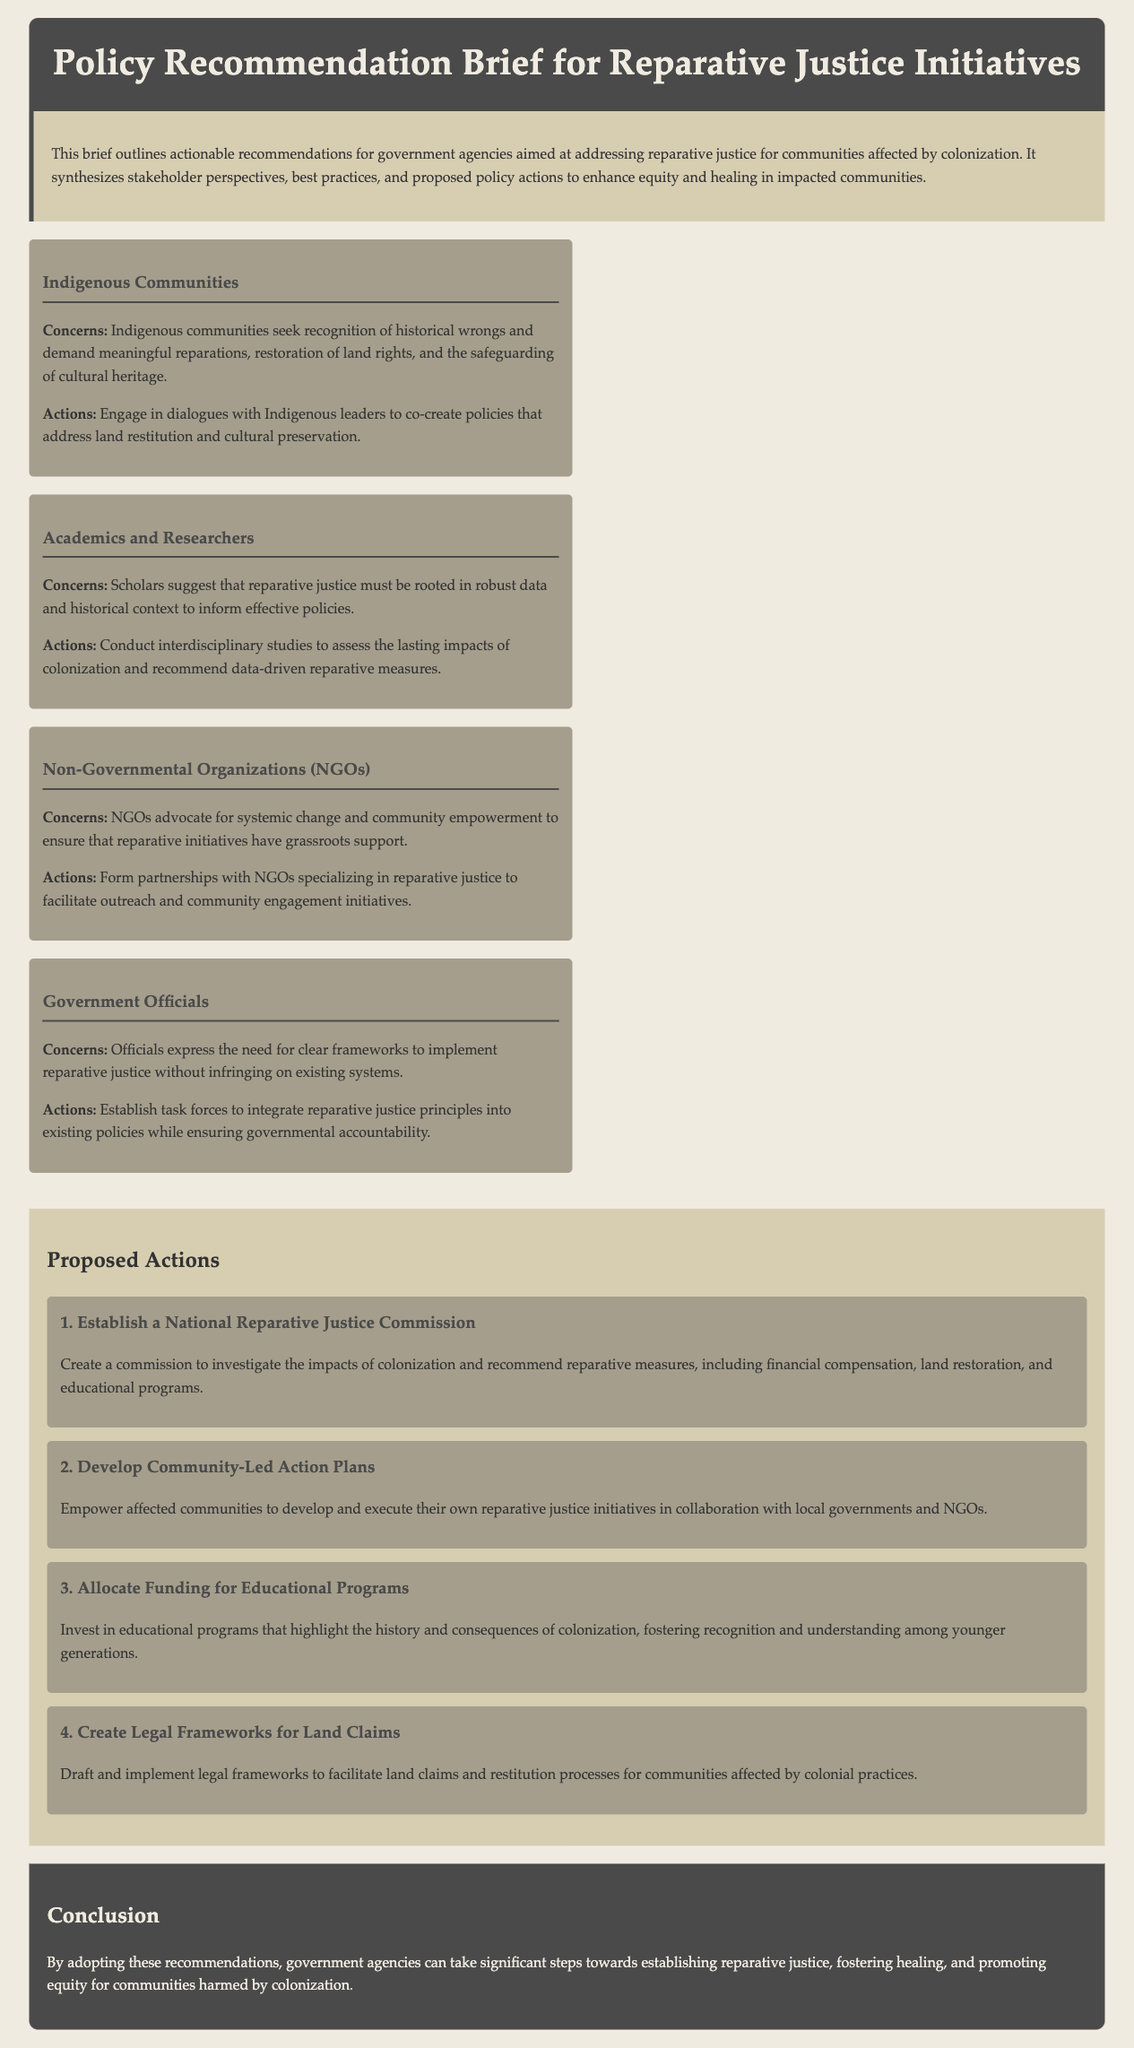what is the title of the document? The title is provided in the header section of the document.
Answer: Policy Recommendation Brief for Reparative Justice Initiatives who are the four stakeholders mentioned? The stakeholders are listed in the stakeholder perspectives section.
Answer: Indigenous Communities, Academics and Researchers, Non-Governmental Organizations (NGOs), Government Officials what is one of the actions proposed for Indigenous Communities? The actions for Indigenous Communities are detailed in their respective section.
Answer: Engage in dialogues with Indigenous leaders how many proposed actions are listed in the document? The number of actions is presented in the proposed actions section, counted by the individual action listings.
Answer: 4 what is the first proposed action? The first proposed action is described in the proposed actions section.
Answer: Establish a National Reparative Justice Commission what color is used for the conclusion section? The color of the conclusion section is specified in the styling instructions.
Answer: #4a4a4a which stakeholder emphasizes the need for data in reparative justice? The emphasis on data comes from the section discussing the stakeholder perspectives.
Answer: Academics and Researchers what is recommended for community empowerment? The recommendation for community empowerment is stated in the proposed actions section.
Answer: Develop Community-Led Action Plans 